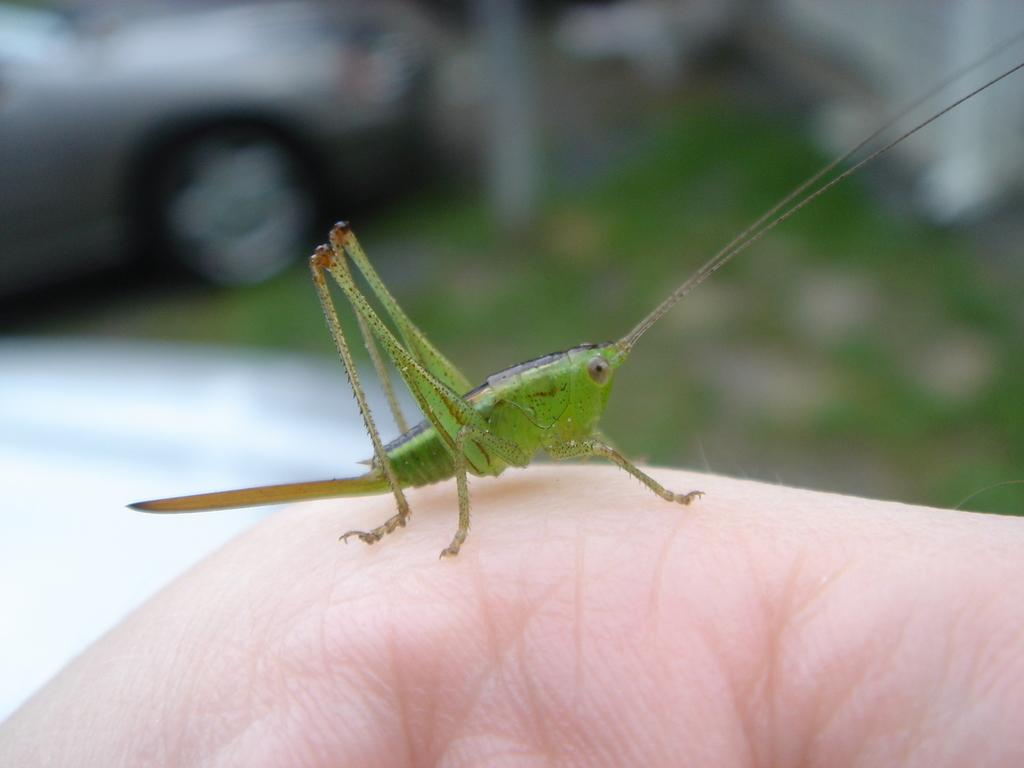What is on the person's hand in the image? There is an insect on the person's hand in the image. What can be seen in the background of the image? There is a car and grass in the background of the image. Can you describe the overall quality of the image? The image is blurry. How many sisters are sitting in the library in the image? There is no library or sisters present in the image. What type of sack is being used to carry the insect in the image? There is no sack present in the image; the insect is on the person's hand. 